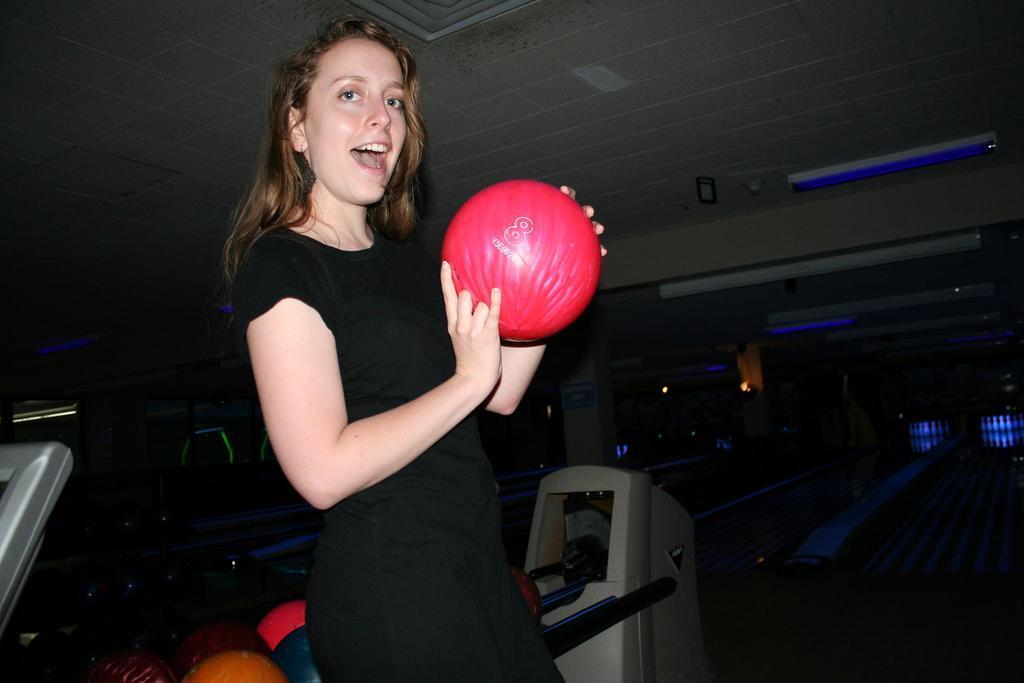How would you summarize this image in a sentence or two? In this image, we can see a person holding a ball. We can see the ground with some objects. We can also see the roof with some lights. We can see a pillar. We can also see some balls and objects. 